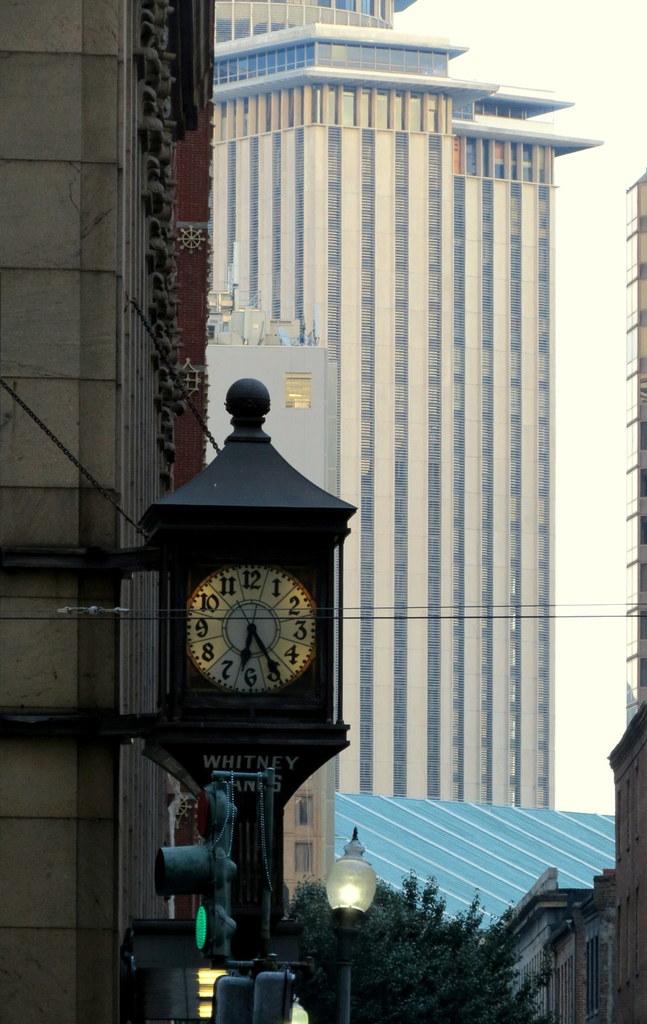What is the time indicated by the clock?
Your answer should be compact. 6:25. 